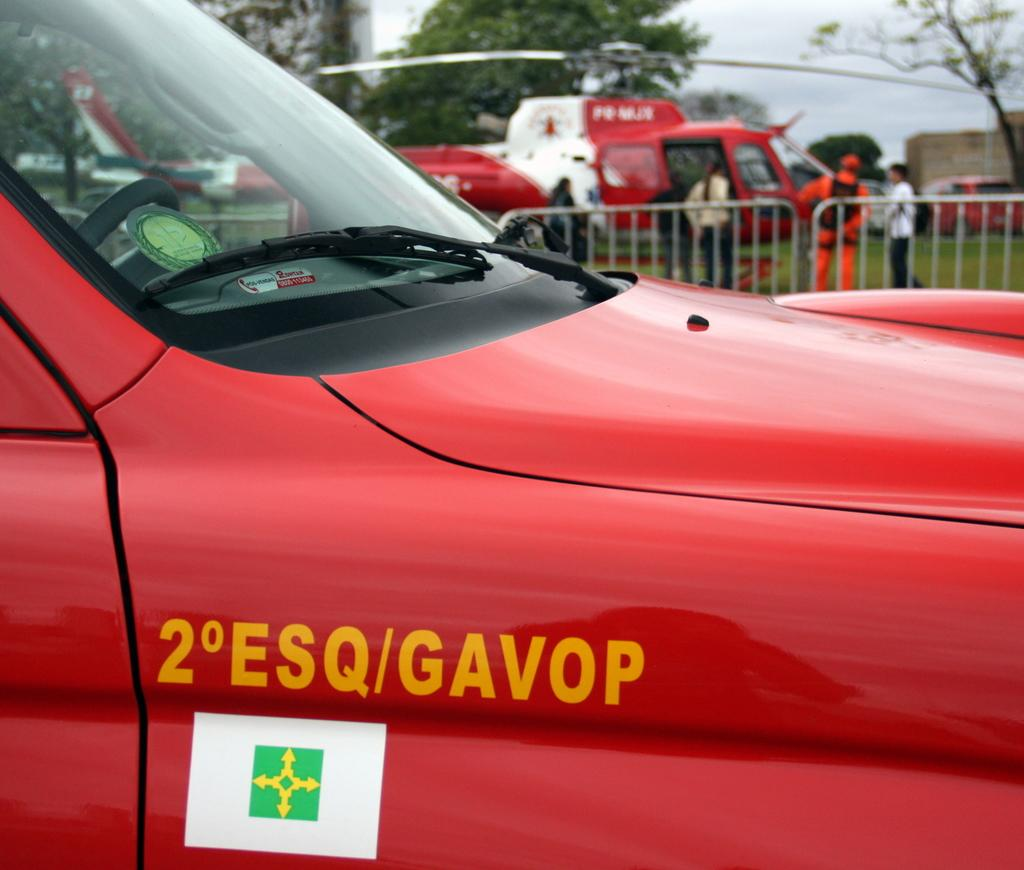Provide a one-sentence caption for the provided image. A red vehicle with the word Gavop written in yellow on it. 